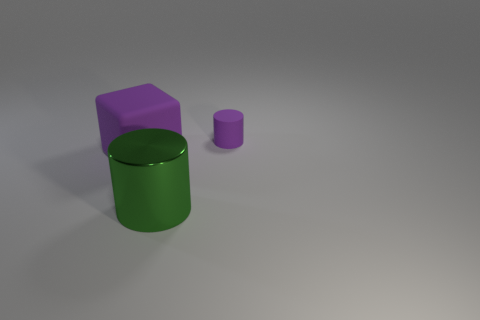What size is the matte thing that is the same shape as the large shiny thing?
Your response must be concise. Small. The purple cylinder has what size?
Ensure brevity in your answer.  Small. There is a cube that is the same material as the small purple object; what color is it?
Your answer should be very brief. Purple. How many cylinders have the same material as the purple block?
Provide a succinct answer. 1. What number of objects are tiny rubber spheres or purple matte objects on the left side of the small purple thing?
Provide a succinct answer. 1. Are the purple thing that is on the left side of the small purple object and the big green cylinder made of the same material?
Your answer should be compact. No. There is a thing that is the same size as the green shiny cylinder; what color is it?
Make the answer very short. Purple. Is there a purple rubber object of the same shape as the big metal object?
Your answer should be compact. Yes. What color is the cylinder that is in front of the cylinder behind the purple matte block that is left of the purple cylinder?
Make the answer very short. Green. What number of metallic things are either big yellow balls or small cylinders?
Your answer should be compact. 0. 